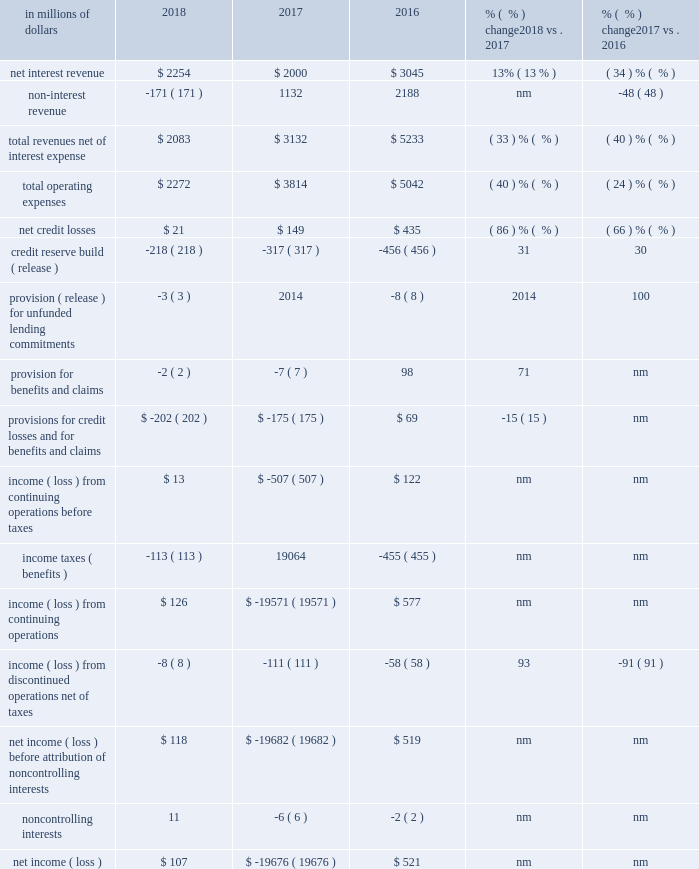Corporate/other corporate/other includes certain unallocated costs of global staff functions ( including finance , risk , human resources , legal and compliance ) , other corporate expenses and unallocated global operations and technology expenses and income taxes , as well as corporate treasury , certain north america legacy consumer loan portfolios , other legacy assets and discontinued operations ( for additional information on corporate/other , see 201ccitigroup segments 201d above ) .
At december 31 , 2018 , corporate/other had $ 91 billion in assets , an increase of 17% ( 17 % ) from the prior year .
In millions of dollars 2018 2017 2016 % (  % ) change 2018 vs .
2017 % (  % ) change 2017 vs .
2016 .
Nm not meaningful 2018 vs .
2017 net income was $ 107 million in 2018 , compared to a net loss of $ 19.7 billion in the prior year , primarily driven by the $ 19.8 billion one-time , non-cash charge recorded in the tax line in 2017 due to the impact of tax reform .
Results in 2018 included the one-time benefit of $ 94 million in the tax line , related to tax reform .
For additional information , see 201csignificant accounting policies and significant estimates 2014income taxes 201d below .
Excluding the one-time impact of tax reform in 2018 and 2017 , net income decreased 92% ( 92 % ) , reflecting lower revenues , partially offset by lower expenses , lower cost of credit and tax benefits related to the reorganization of certain non-u.s .
Subsidiaries .
The tax benefits were largely offset by the release of a foreign currency translation adjustment ( cta ) from aoci to earnings ( for additional information on the cta release , see note 19 to the consolidated financial statements ) .
Revenues decreased 33% ( 33 % ) , driven by the continued wind-down of legacy assets .
Expenses decreased 40% ( 40 % ) , primarily driven by the wind-down of legacy assets , lower infrastructure costs and lower legal expenses .
Provisions decreased $ 27 million to a net benefit of $ 202 million , primarily due to lower net credit losses , partially offset by a lower net loan loss reserve release .
Net credit losses declined 86% ( 86 % ) to $ 21 million , primarily reflecting the impact of ongoing divestiture activity and the continued wind-down of the north america mortgage portfolio .
The net reserve release declined by $ 96 million to $ 221 million , and reflected the continued wind-down of the legacy north america mortgage portfolio and divestitures .
2017 vs .
2016 the net loss was $ 19.7 billion , compared to net income of $ 521 million in the prior year , primarily driven by the one-time impact of tax reform .
Excluding the one-time impact of tax reform , net income declined 69% ( 69 % ) to $ 168 million , reflecting lower revenues , partially offset by lower expenses and lower cost of credit .
Revenues declined 40% ( 40 % ) , primarily reflecting the continued wind-down of legacy assets and the absence of gains related to debt buybacks in 2016 .
Revenues included approximately $ 750 million in gains on asset sales in the first quarter of 2017 , which more than offset a roughly $ 300 million charge related to the exit of citi 2019s u.s .
Mortgage servicing operations in the quarter .
Expenses declined 24% ( 24 % ) , reflecting the wind-down of legacy assets and lower legal expenses , partially offset by approximately $ 100 million in episodic expenses primarily related to the exit of the u.s .
Mortgage servicing operations .
Also included in expenses is an approximately $ 255 million provision for remediation costs related to a card act matter in 2017 .
Provisions decreased $ 244 million to a net benefit of $ 175 million , primarily due to lower net credit losses and a lower provision for benefits and claims , partially offset by a lower net loan loss reserve release .
Net credit losses declined 66% ( 66 % ) , primarily reflecting the impact of ongoing divestiture activity and the continued wind-down of the north america mortgage portfolio .
The decline in the provision for benefits and claims was primarily due to lower insurance activity .
The net reserve release declined $ 147 million , and reflected the continued wind-down of the legacy north america mortgage portfolio and divestitures. .
What was the percentage change in total operating expenses between 2016 and 2018? 
Computations: ((2272 - 5042) / 5042)
Answer: -0.54939. 